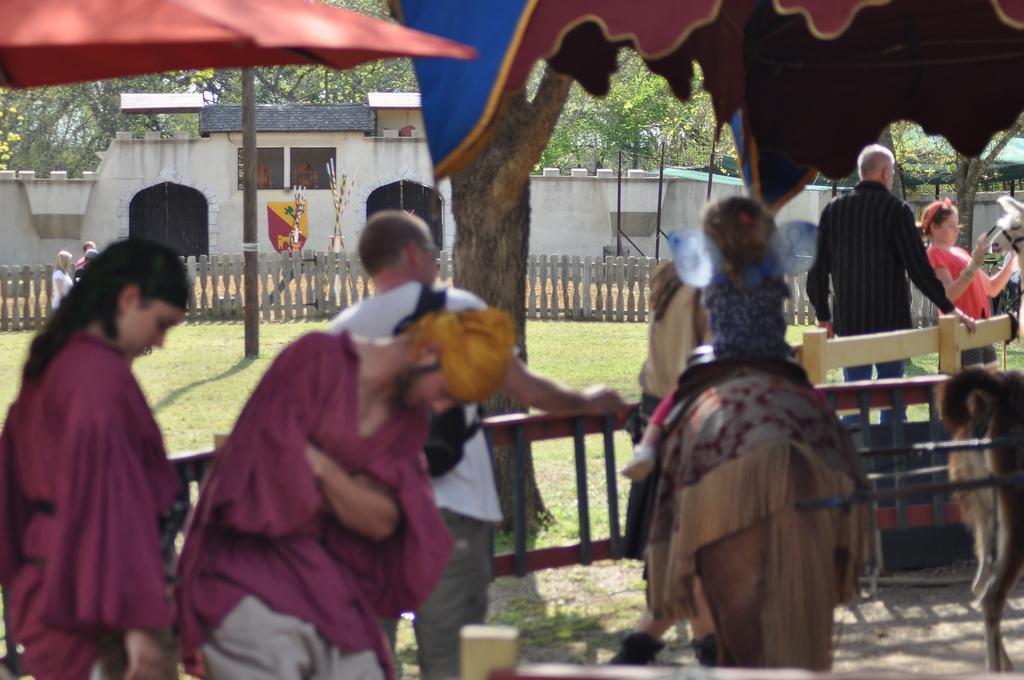Describe this image in one or two sentences. This is a picture taken in the outdoors. It is sunny. There are group of people standing on the floor and a girl is riding a horse. Background of this people is a fencing, building and trees. 